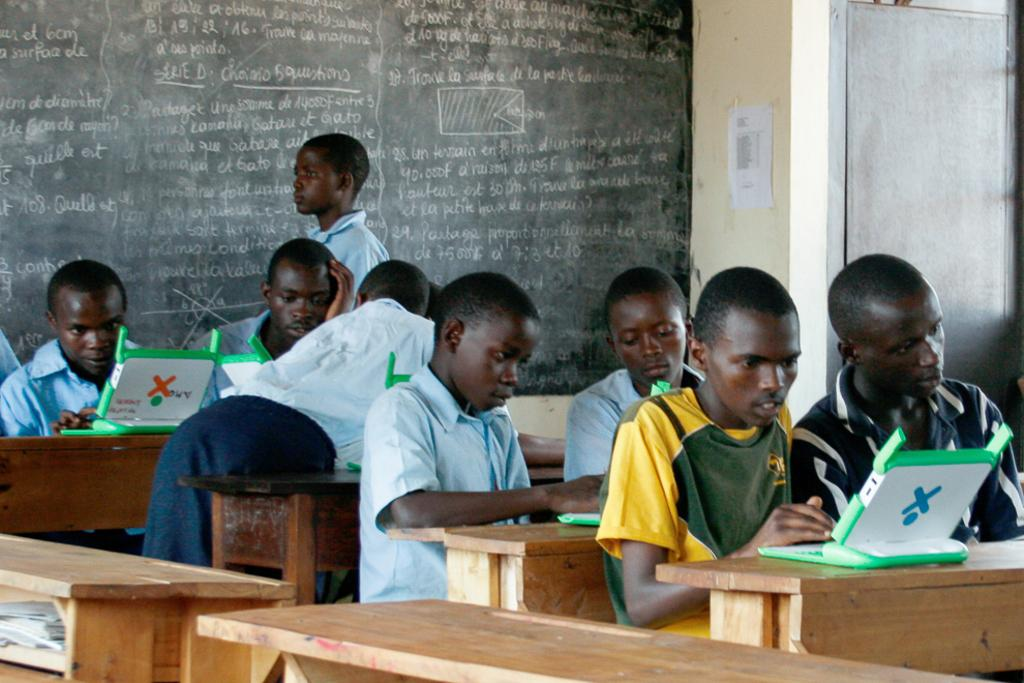What is the setting of the image? The image is taken in a class. What type of furniture is present in the image? There are tables in the image. What color are the tables? The tables are yellow. What are the kids doing in the image? The kids are sitting on the tables. What can be seen on the wall in the background? There is a black color board in the background. What type of breakfast is being served to the kids in the image? There is no breakfast being served in the image; it is focused on the kids sitting on the yellow tables in a class setting. 